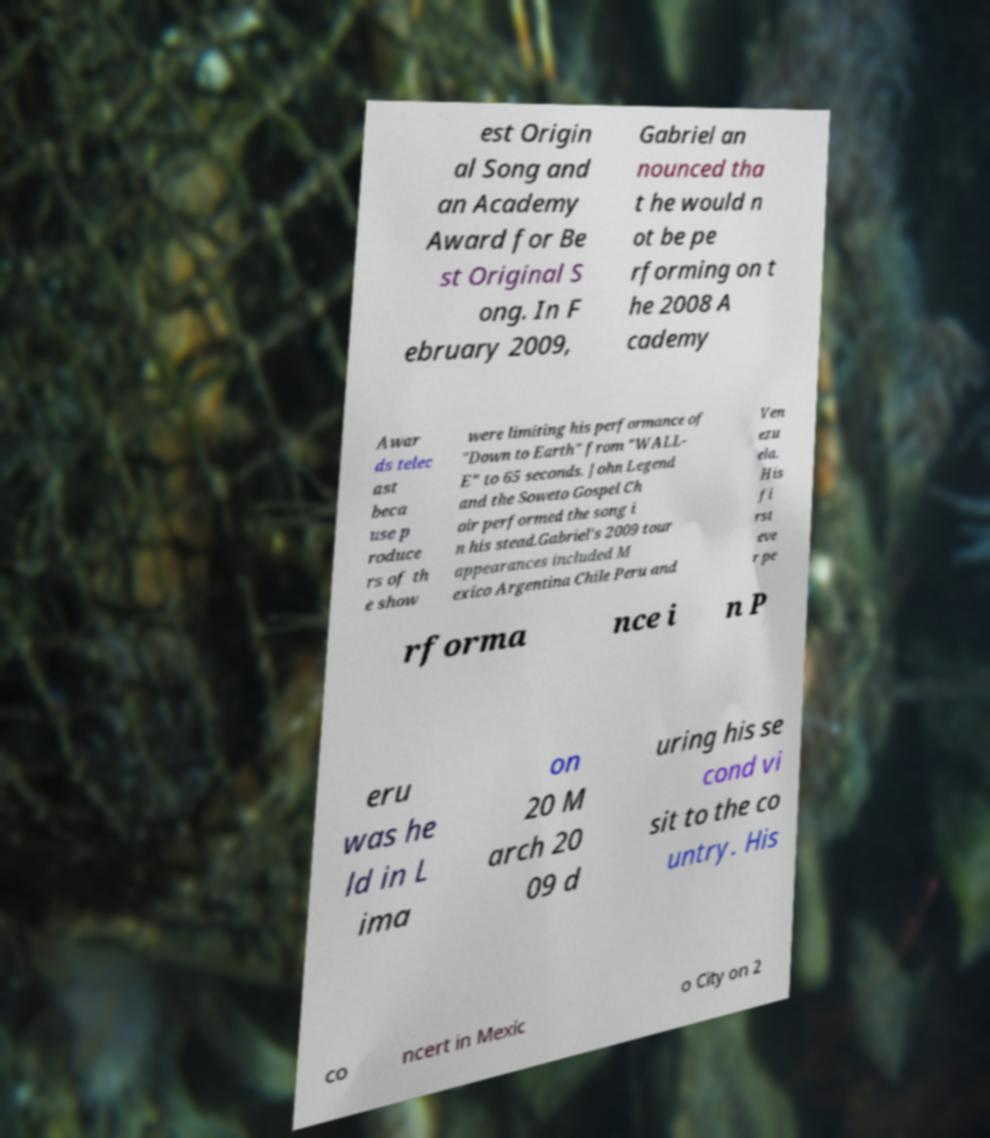For documentation purposes, I need the text within this image transcribed. Could you provide that? est Origin al Song and an Academy Award for Be st Original S ong. In F ebruary 2009, Gabriel an nounced tha t he would n ot be pe rforming on t he 2008 A cademy Awar ds telec ast beca use p roduce rs of th e show were limiting his performance of "Down to Earth" from "WALL- E" to 65 seconds. John Legend and the Soweto Gospel Ch oir performed the song i n his stead.Gabriel's 2009 tour appearances included M exico Argentina Chile Peru and Ven ezu ela. His fi rst eve r pe rforma nce i n P eru was he ld in L ima on 20 M arch 20 09 d uring his se cond vi sit to the co untry. His co ncert in Mexic o City on 2 